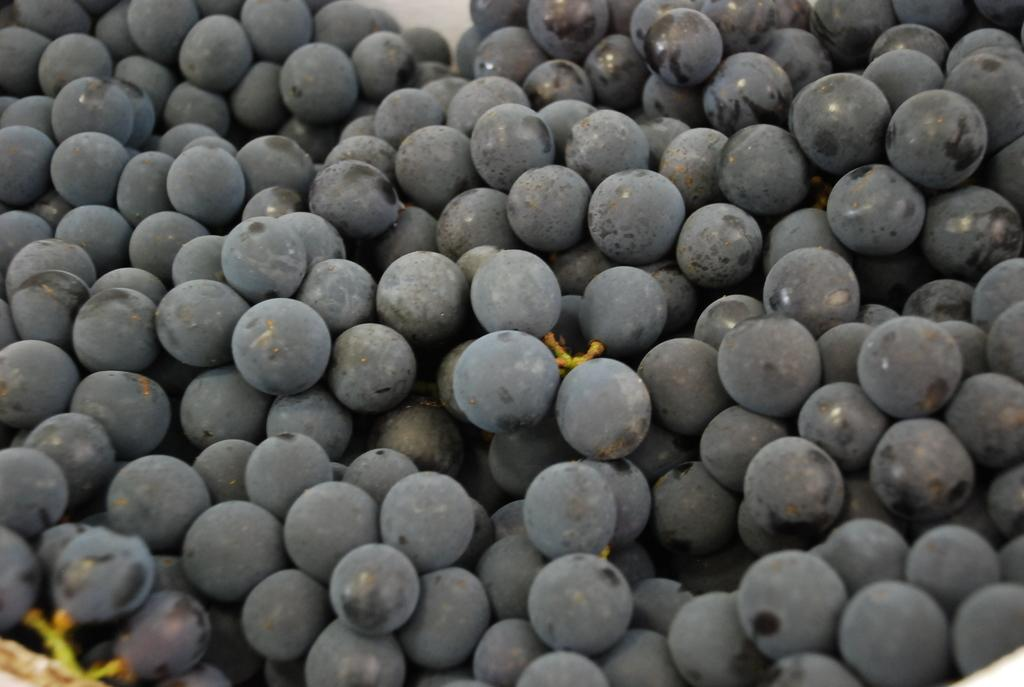What type of food can be seen in the image? There are fruits in the image. Can you describe the appearance of the fruits? The fruits resemble black grapes. What type of crate is used to store the popcorn in the image? There is no crate or popcorn present in the image; it features fruits resembling black grapes. 